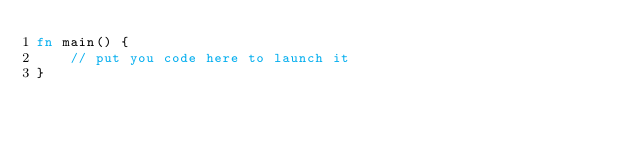Convert code to text. <code><loc_0><loc_0><loc_500><loc_500><_Rust_>fn main() {
    // put you code here to launch it
}
</code> 